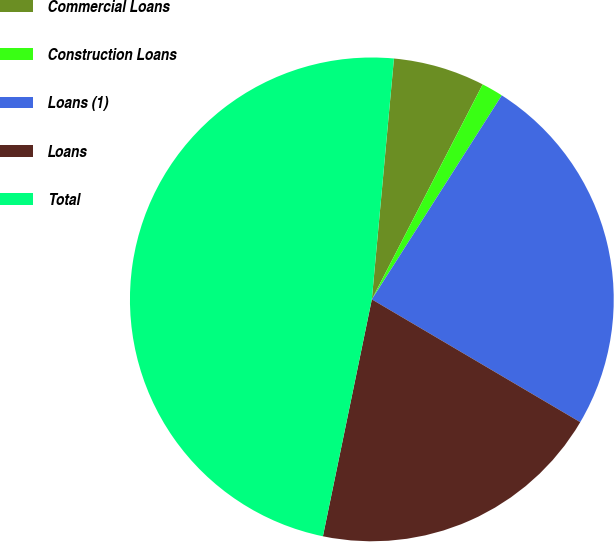Convert chart to OTSL. <chart><loc_0><loc_0><loc_500><loc_500><pie_chart><fcel>Commercial Loans<fcel>Construction Loans<fcel>Loans (1)<fcel>Loans<fcel>Total<nl><fcel>6.12%<fcel>1.45%<fcel>24.45%<fcel>19.77%<fcel>48.22%<nl></chart> 